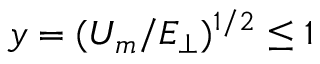<formula> <loc_0><loc_0><loc_500><loc_500>y = ( U _ { m } / E _ { \perp } ) ^ { 1 / 2 } \leq 1</formula> 